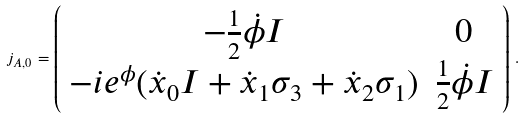Convert formula to latex. <formula><loc_0><loc_0><loc_500><loc_500>j _ { A , 0 } = \left ( \begin{array} { c c } - \frac { 1 } { 2 } \dot { \phi } I & 0 \\ - i e ^ { \phi } ( \dot { x } _ { 0 } I + \dot { x } _ { 1 } \sigma _ { 3 } + \dot { x } _ { 2 } \sigma _ { 1 } ) & \frac { 1 } { 2 } \dot { \phi } I \end{array} \right ) \, .</formula> 